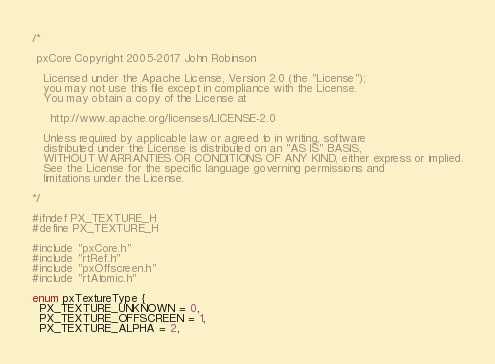<code> <loc_0><loc_0><loc_500><loc_500><_C_>/*

 pxCore Copyright 2005-2017 John Robinson

   Licensed under the Apache License, Version 2.0 (the "License");
   you may not use this file except in compliance with the License.
   You may obtain a copy of the License at

     http://www.apache.org/licenses/LICENSE-2.0

   Unless required by applicable law or agreed to in writing, software
   distributed under the License is distributed on an "AS IS" BASIS,
   WITHOUT WARRANTIES OR CONDITIONS OF ANY KIND, either express or implied.
   See the License for the specific language governing permissions and
   limitations under the License.

*/

#ifndef PX_TEXTURE_H
#define PX_TEXTURE_H

#include "pxCore.h"
#include "rtRef.h"
#include "pxOffscreen.h"
#include "rtAtomic.h"

enum pxTextureType { 
  PX_TEXTURE_UNKNOWN = 0,
  PX_TEXTURE_OFFSCREEN = 1, 
  PX_TEXTURE_ALPHA = 2, </code> 